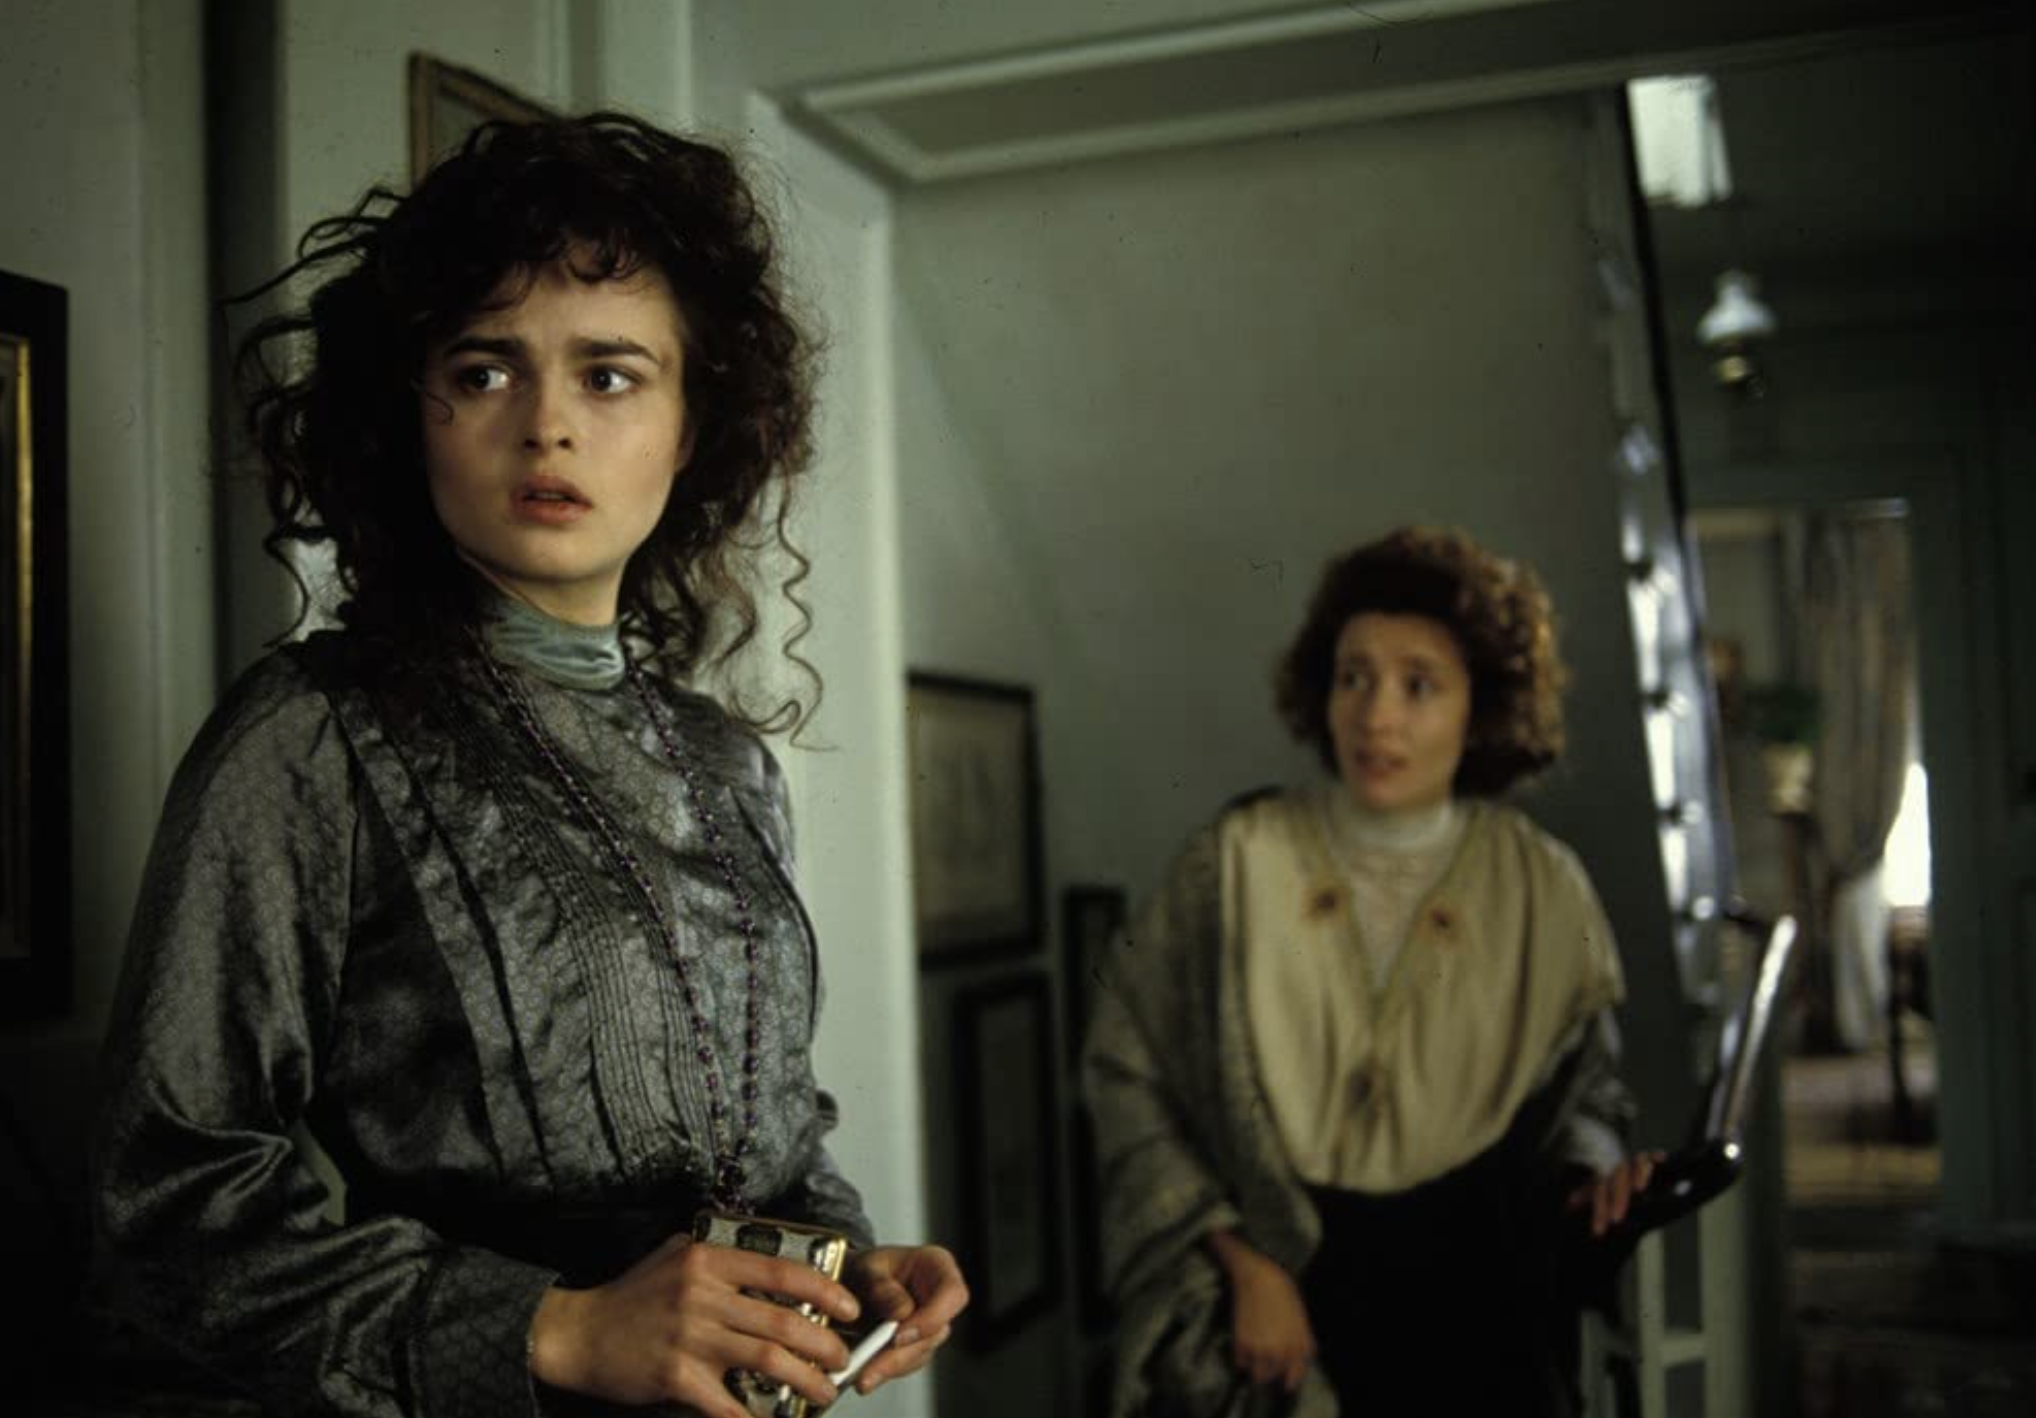What do you think the two characters are discussing in this moment? Given the worried expression on Lucy's face and the slightly agitated posture of Charlotte, it seems they are discussing a matter of significant concern or urgency. Perhaps Charlotte is informing Lucy of a pressing social expectation or disclosing news that affects Lucy deeply. 